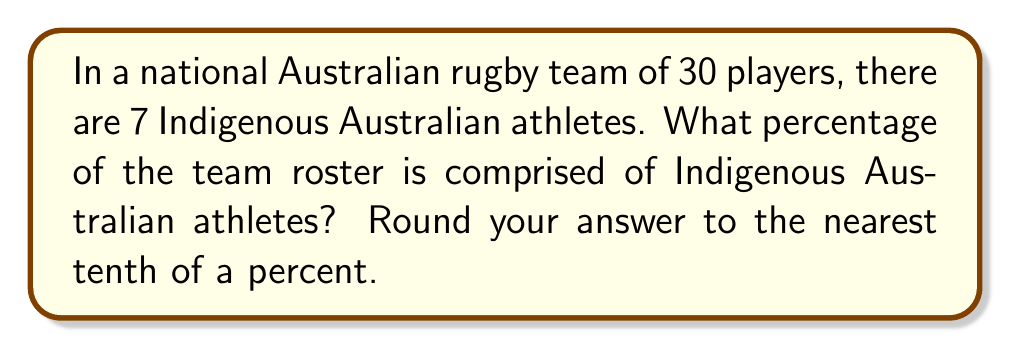Solve this math problem. To determine the percentage of Indigenous Australian athletes in the team roster, we need to follow these steps:

1. Identify the total number of players and the number of Indigenous Australian athletes:
   Total players: 30
   Indigenous Australian athletes: 7

2. Set up the percentage calculation:
   Percentage = (Part / Whole) × 100
   
3. Substitute the values:
   Percentage = (7 / 30) × 100

4. Perform the division:
   $7 \div 30 = 0.2333...$

5. Multiply by 100:
   $0.2333... \times 100 = 23.33...\%$

6. Round to the nearest tenth of a percent:
   $23.3\%$

Therefore, the percentage of Indigenous Australian athletes in the national team roster is 23.3%.
Answer: $23.3\%$ 